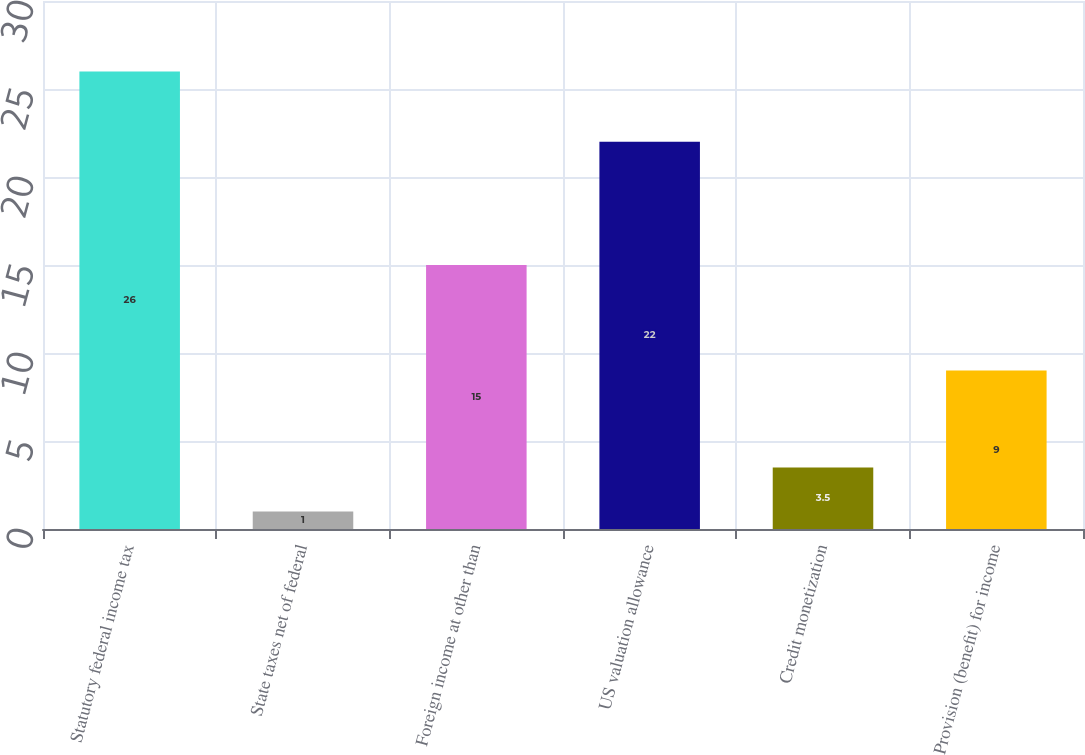Convert chart to OTSL. <chart><loc_0><loc_0><loc_500><loc_500><bar_chart><fcel>Statutory federal income tax<fcel>State taxes net of federal<fcel>Foreign income at other than<fcel>US valuation allowance<fcel>Credit monetization<fcel>Provision (benefit) for income<nl><fcel>26<fcel>1<fcel>15<fcel>22<fcel>3.5<fcel>9<nl></chart> 